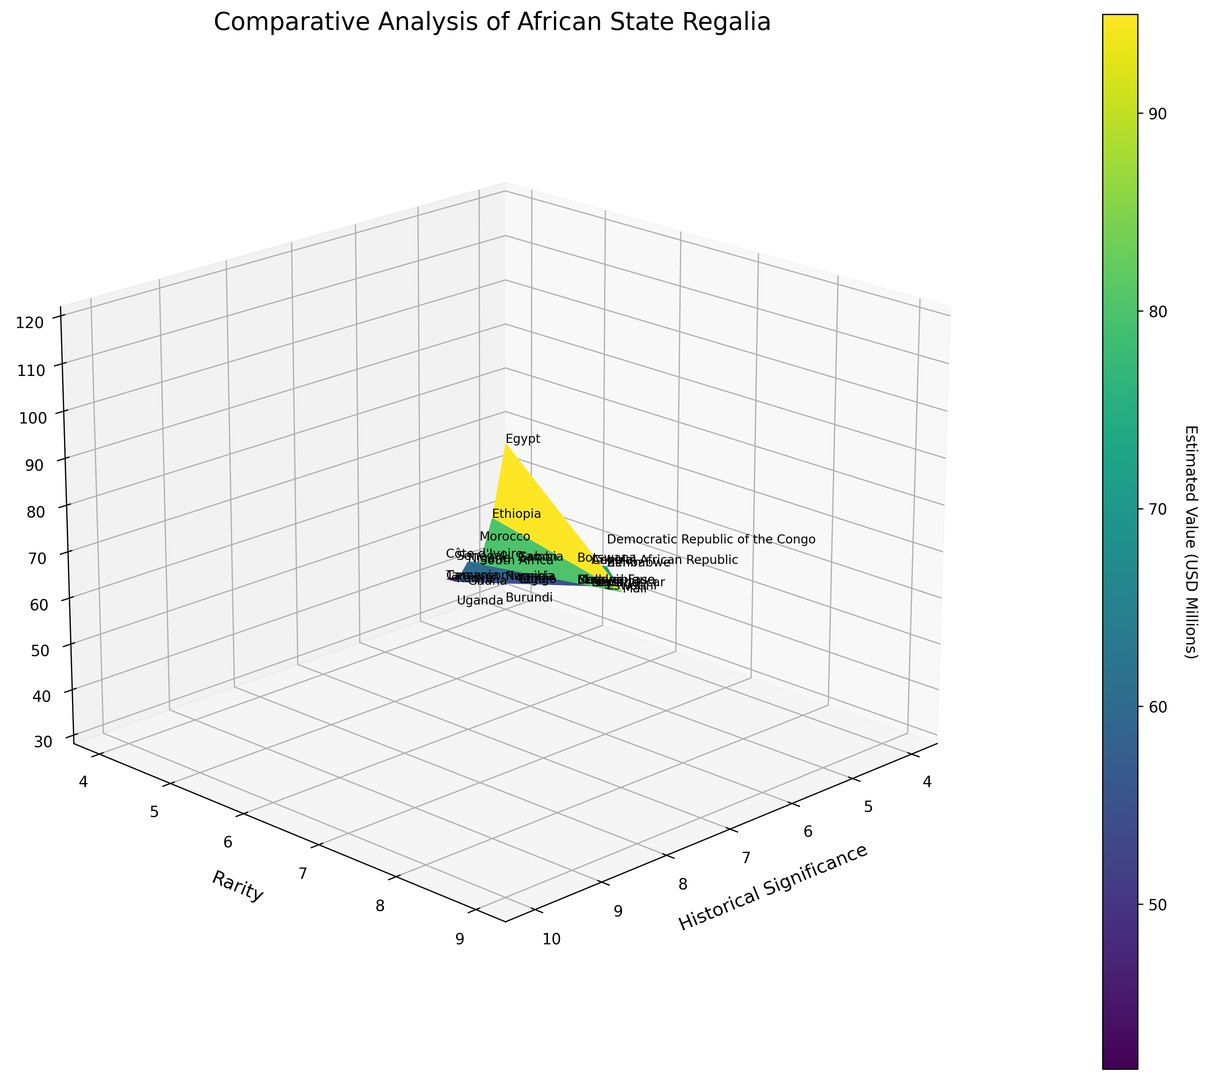What is the correlation between historical significance and estimated value? The figure plots historical significance on one axis and estimated value on another. By looking at the overall trend in the surface plot, we can infer that higher historical significance generally correlates with higher estimated value.
Answer: Positive correlation Which country has the highest estimated value of state regalia? In the figure, the estimated value is indicated by the height of the surface plot. The peak value appears to be associated with Egypt.
Answer: Egypt Between Nigeria and South Africa, which country has a higher rarity in their state regalia? The y-axis represents rarity, and by comparing their positions along this axis, one can see that South Africa has a higher rarity value than Nigeria.
Answer: South Africa Compare the estimated value of Kenya and Zambia. Which country has a higher estimated value? The z-axis represents the estimated value. By visually comparing the points for Kenya and Zambia along the z-axis, it's clear that Kenya's estimated value is higher than Zambia's.
Answer: Kenya Which countries have both historical significance and rarity values under 5, and what are their estimated values? By examining points on the plot that lie in the region where both the x and y values are under 5, we identify Namibia, Rwanda, Burundi. Their estimated values are identified along the z-axis. Namibia: 35, Rwanda: 35, Burundi: 30.
Answer: Namibia: 35, Rwanda: 35, Burundi: 30 What is the overall trend between rarity and estimated value? The surface plot shows an increasing z-axis value as the y-axis value (rarity) increases, indicating that higher rarity corresponds with higher estimated values.
Answer: Higher rarity, higher value Which country with a historical significance value of 6 has the highest estimated value? By isolating the points on the plot where the x-axis value is 6 (historical significance), we compare their z-axis values (estimated value). From the analysis, Zimbabwe has the highest estimated value among these points.
Answer: Zimbabwe What is the estimated value difference between Mali and Democratic Republic of the Congo? By looking at their positions on the z-axis, Mali has an estimated value of 70 million and the Democratic Republic of the Congo has a value of 70 million. The difference is calculated as 0.
Answer: 0 How does the estimated value for Ethiopia compare to that of Botswana in terms of percentage? Ethiopia has an estimated value of 95 million while Botswana has 45 million. The percentage difference is calculated as (95 - 45) / 95 * 100 ≈ 52.63%.
Answer: ≈52.63% What is the range of estimated values for countries with a historical significance value of 5? By identifying the z-axis values for all points where the x-axis value is 5 (historical significance), we see the range from 35 to 55 million USD.
Answer: 35 to 55 million USD 